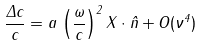Convert formula to latex. <formula><loc_0><loc_0><loc_500><loc_500>\frac { \Delta c } { c } = a \, \left ( \frac { \omega } { c } \right ) ^ { 2 } { X } \cdot { \hat { n } } + O ( \nu ^ { 4 } )</formula> 